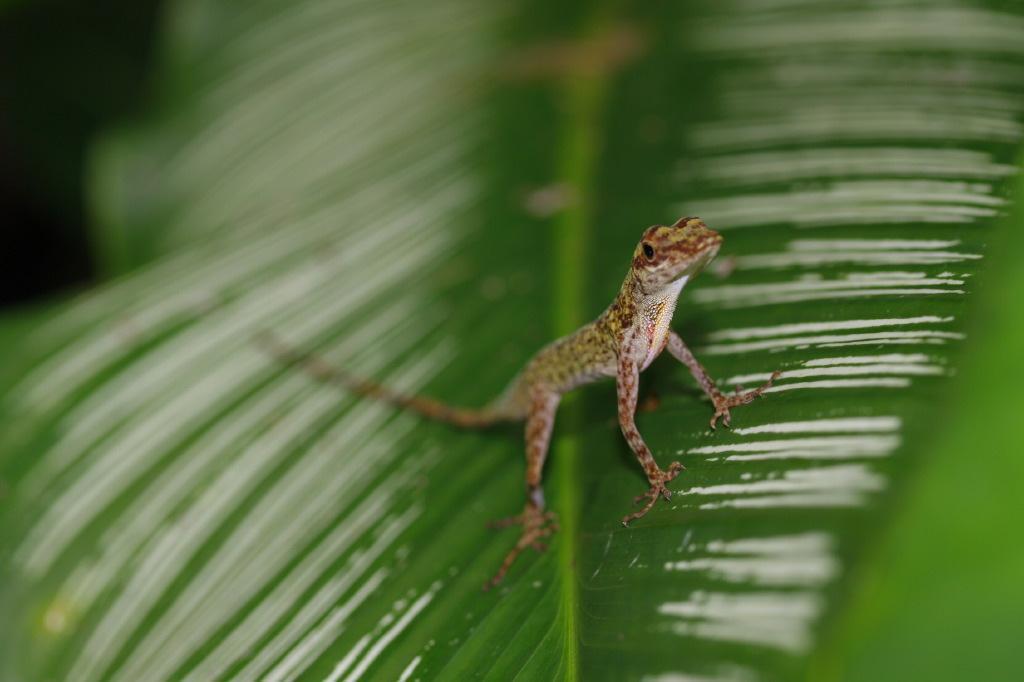In one or two sentences, can you explain what this image depicts? In this picture we can see a brown color lizard sitting on the wet green leaf. 